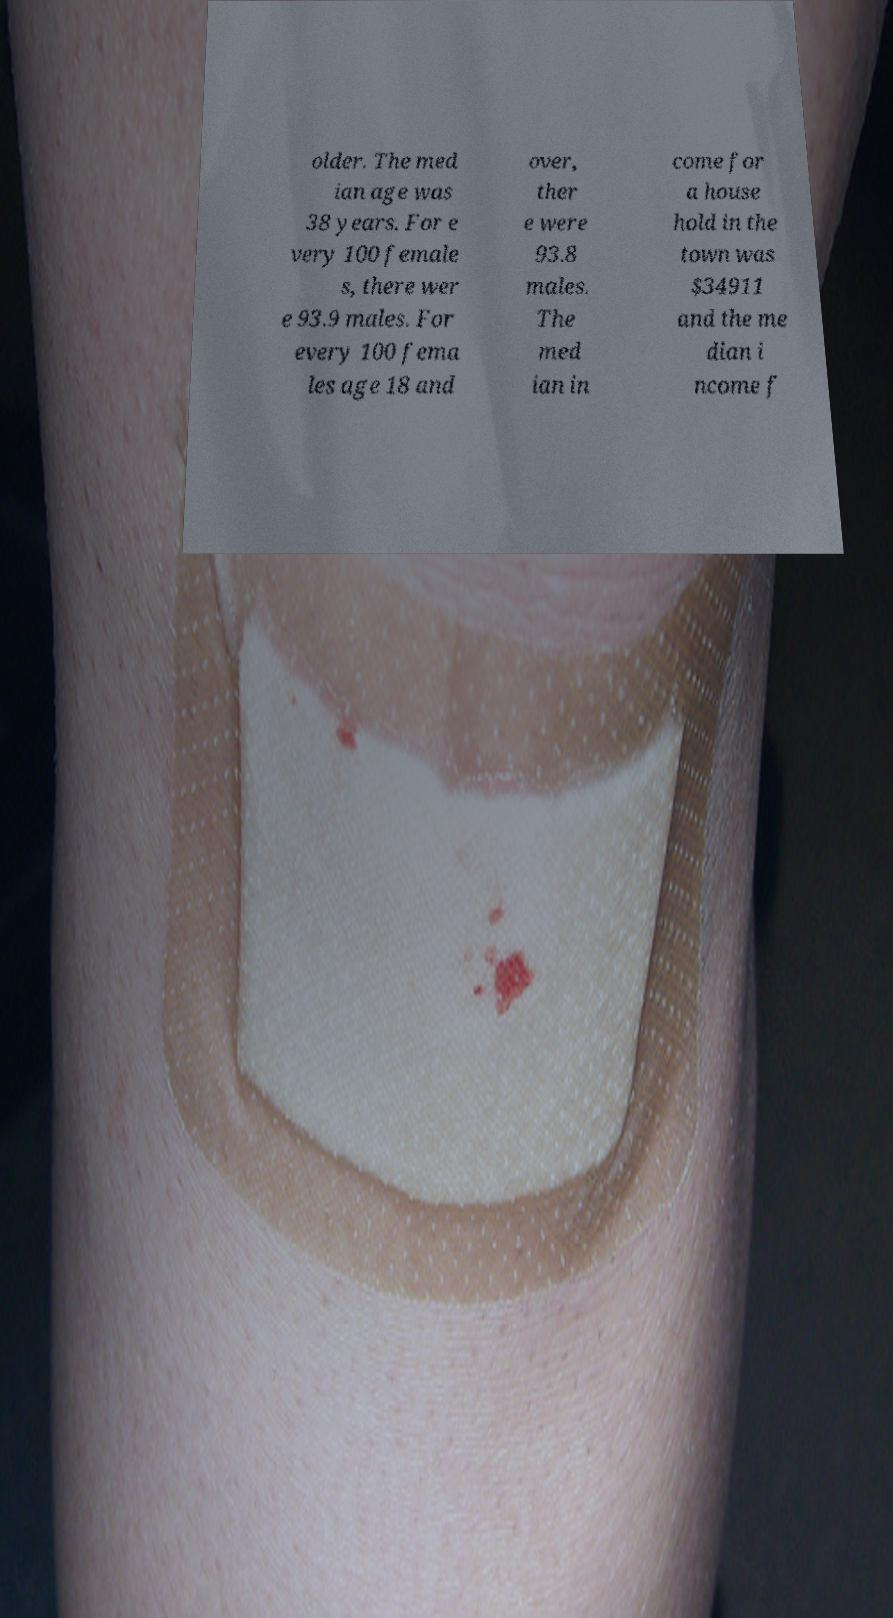Can you read and provide the text displayed in the image?This photo seems to have some interesting text. Can you extract and type it out for me? older. The med ian age was 38 years. For e very 100 female s, there wer e 93.9 males. For every 100 fema les age 18 and over, ther e were 93.8 males. The med ian in come for a house hold in the town was $34911 and the me dian i ncome f 